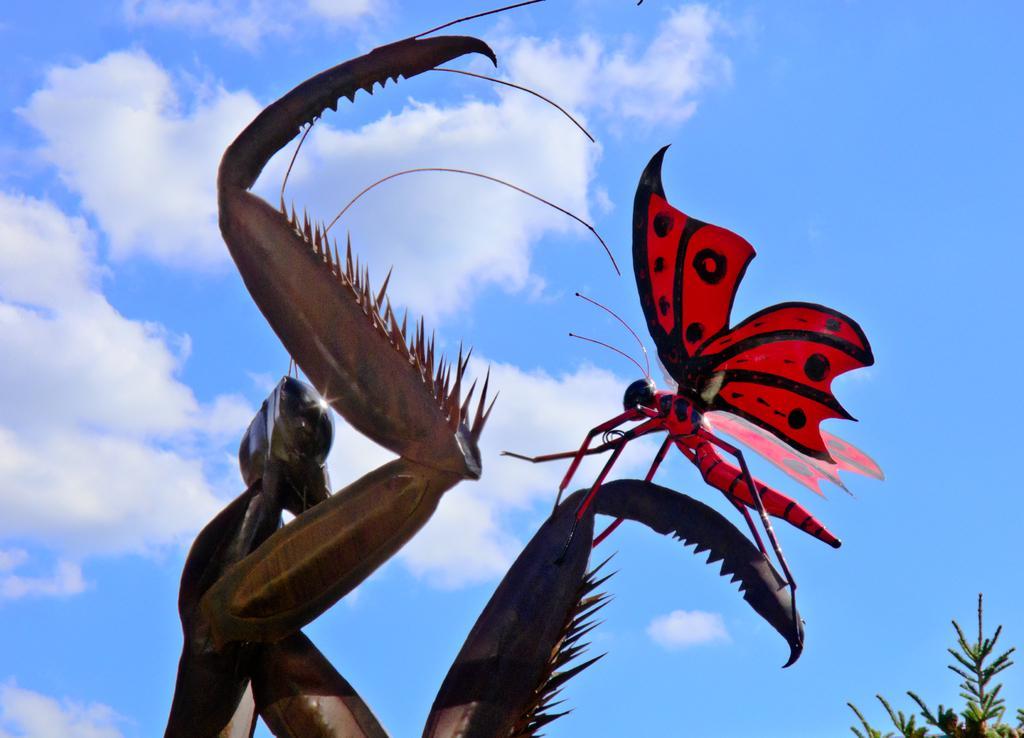Please provide a concise description of this image. In this picture we can see a butterfly,here we can see plants and we can see sky in the background. 